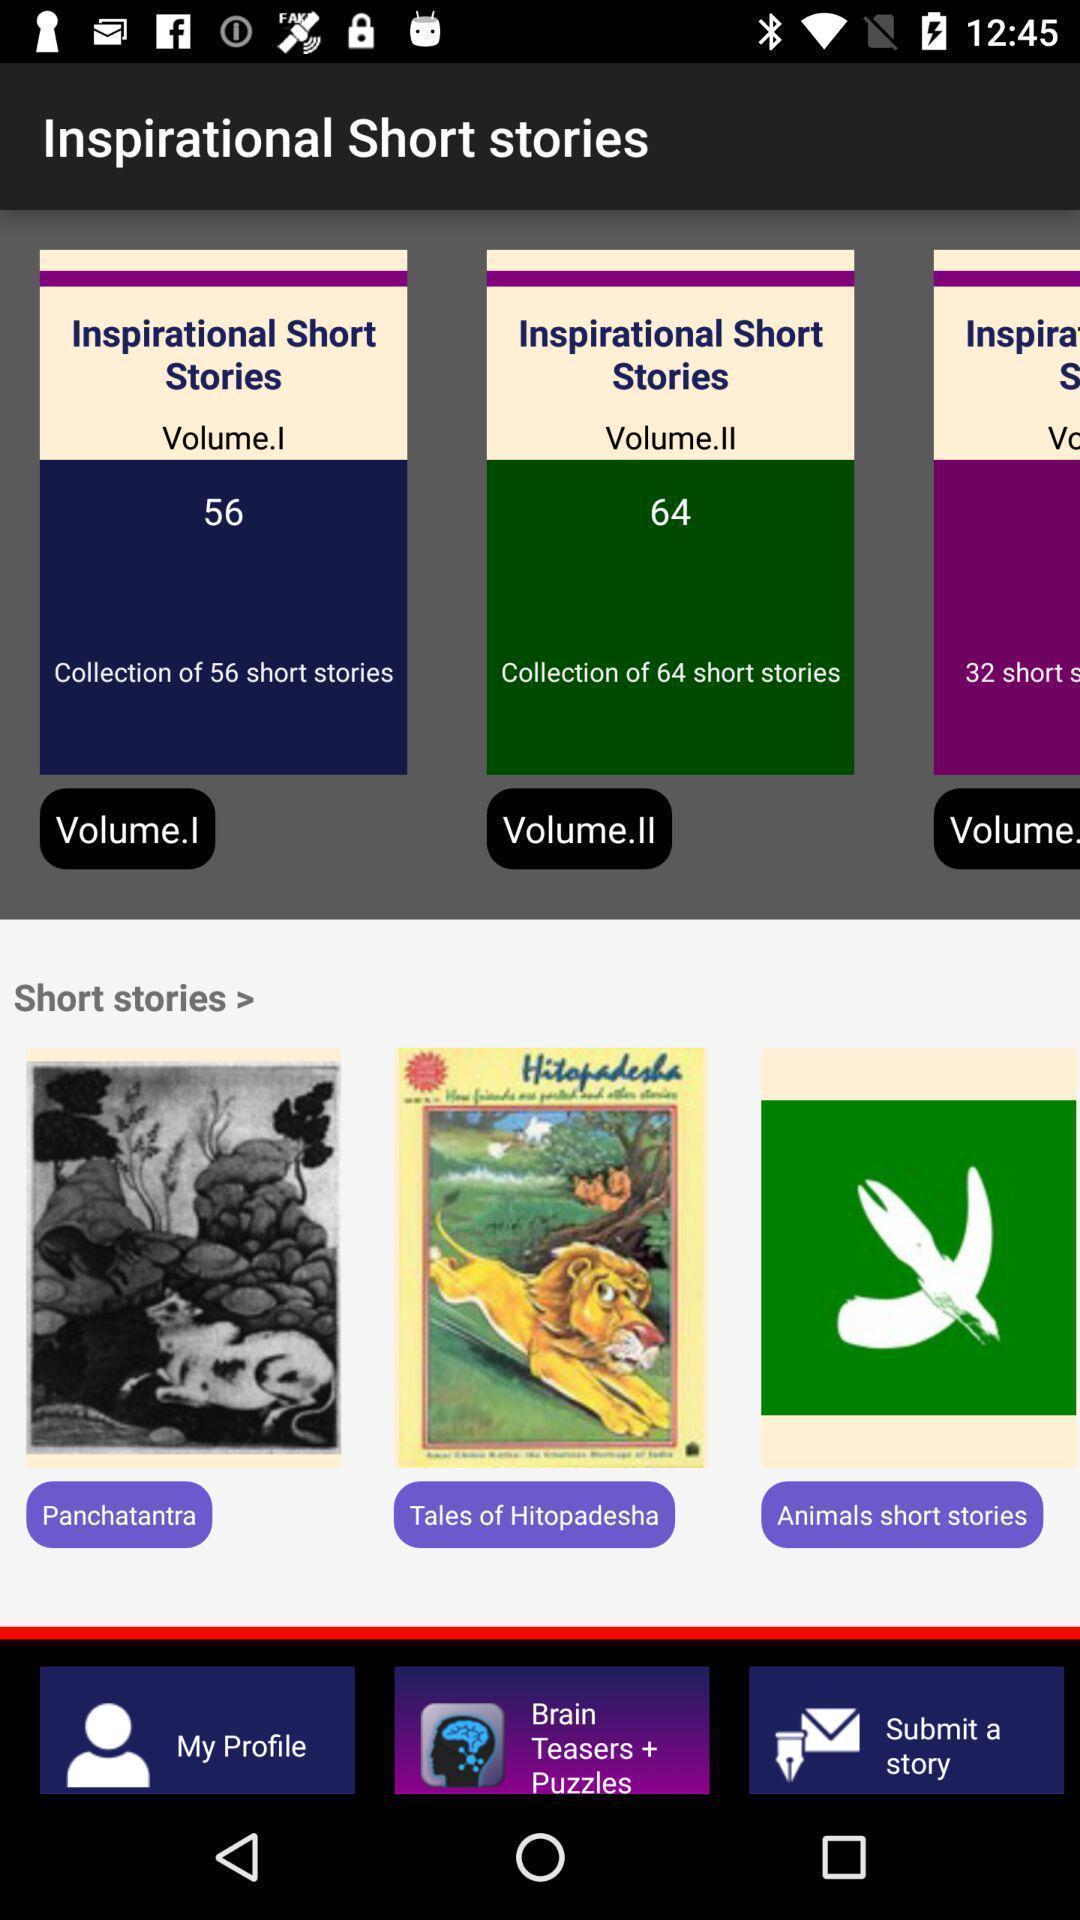Give me a narrative description of this picture. Page showing various categories. 